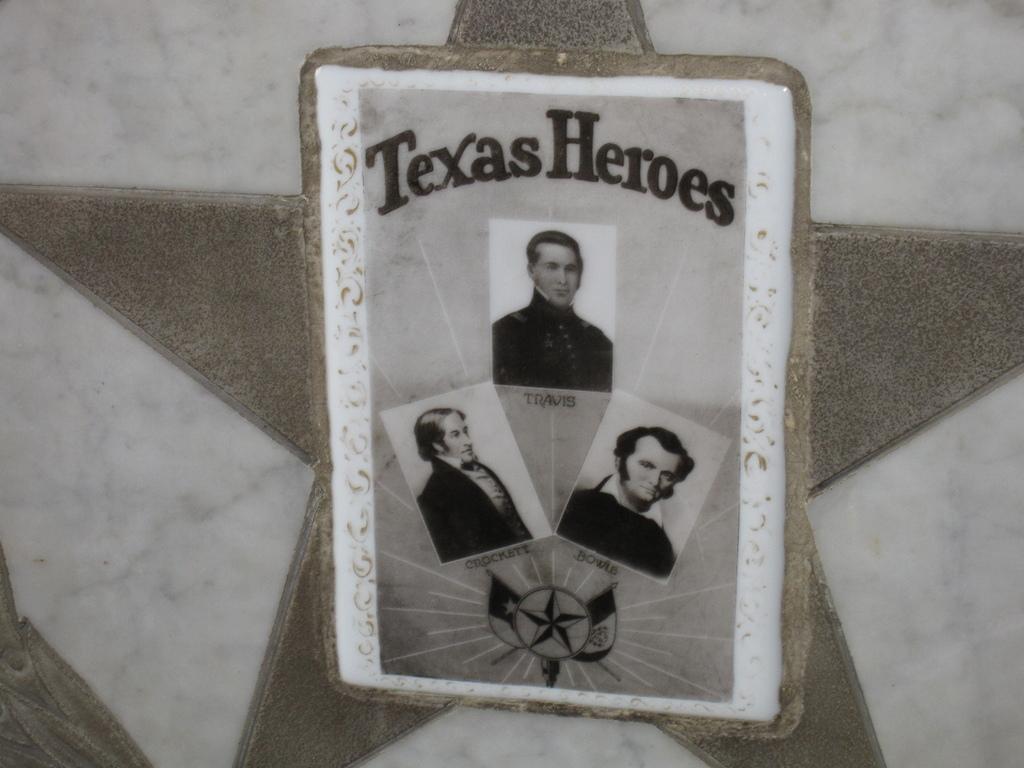How would you summarize this image in a sentence or two? In the image on the white surface there is a star sign. In the middle of the star sign there are three images of men and there is something written on it. At the bottom of the images there is a logo. 